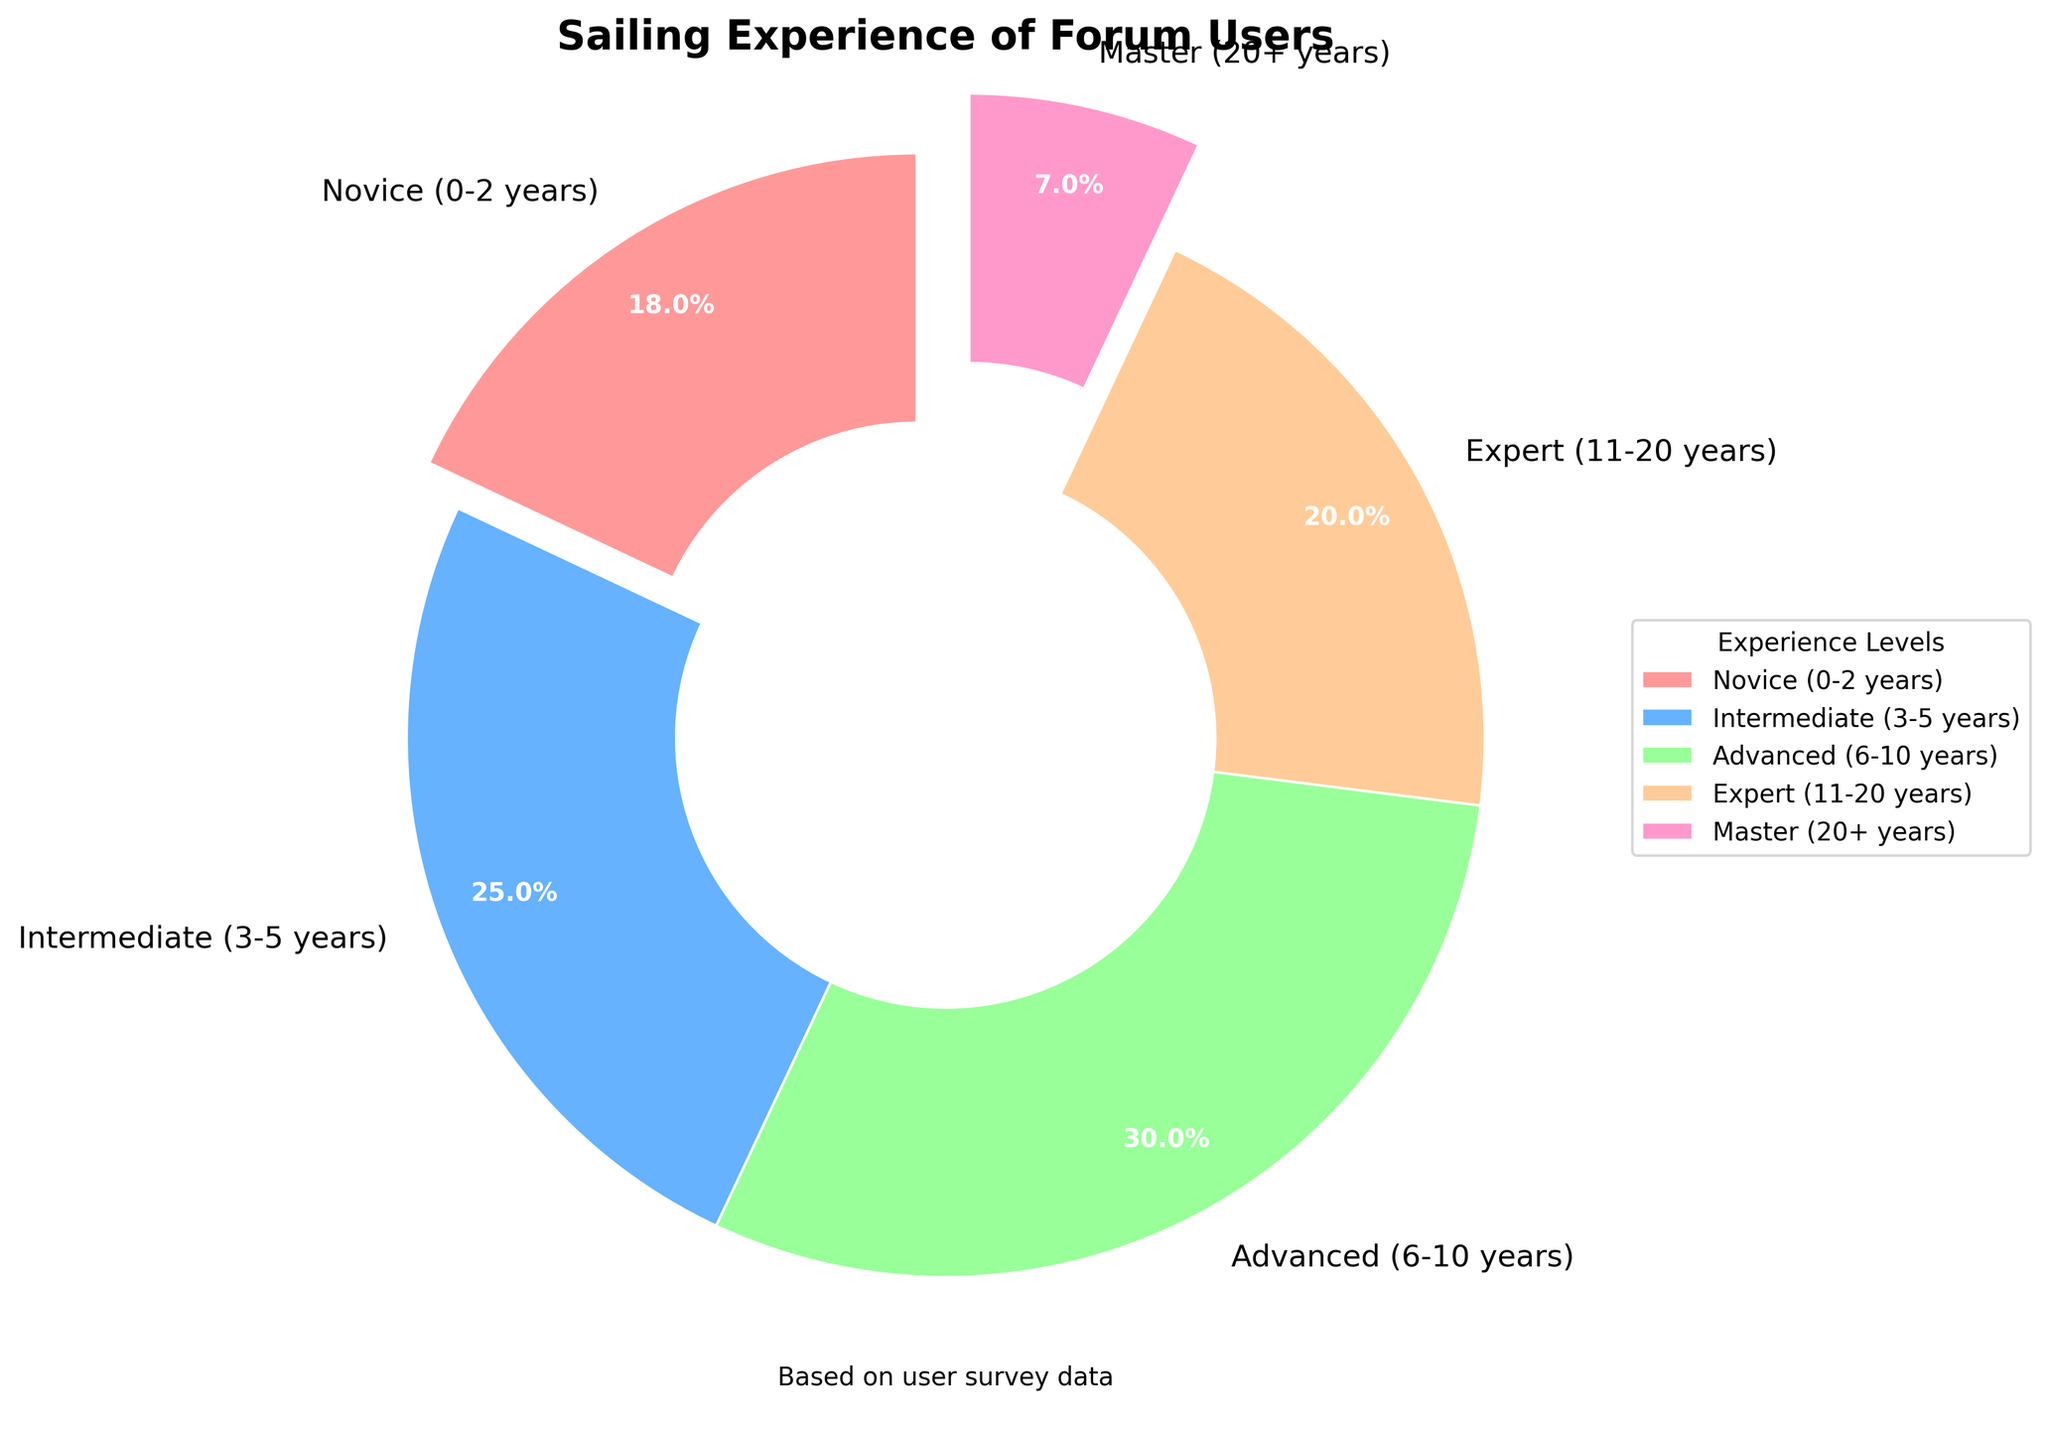What percentage of forum users are considered either Advanced or Expert sailors? To determine this, we sum the percentages of Advanced (30%) and Expert (20%) categories. 30 + 20 = 50%
Answer: 50% Which experience level has the smallest proportion of forum users? By looking at the pie chart, we see that the Master category has the smallest wedge, reflecting 7%.
Answer: Master How many times larger is the Intermediate group compared to the Master group? The Intermediate group is 25%, and the Master group is 7%. To find how many times larger, we divide 25 by 7. 25 / 7 ≈ 3.57
Answer: 3.57 times What is the difference in percentage between the most experienced group and the least experienced group? The Master group (7%) is the most experienced, and the Novice group (18%) is the least. We subtract 7 from 18. 18 - 7 = 11%
Answer: 11% Which two experience levels combined make up half of the forum users? Advanced (30%) and Expert (20%) combined equal 30 + 20 = 50% of the total.
Answer: Advanced and Expert What color is used to represent the Intermediate experience level in the pie chart? By looking at the pie chart, the Intermediate experience level is colored in blue.
Answer: Blue Is the percentage of Novice users greater or lesser than the percentage of Expert users? The Novice group is 18%, and the Expert group is 20%. 18% is less than 20%.
Answer: Lesser What is the visual difference in the pie slices between the Advanced group and the Master group? The Advanced group (30%) has a significantly larger pie slice than the Master group (7%), indicating Advanced is much more prevalent.
Answer: Advanced slice is larger If we were to average the percentages of Novice and Intermediate users, what would be the result? To find the average percentage, add Novice (18%) and Intermediate (25%) and divide by 2. (18 + 25) / 2 = 21.5%
Answer: 21.5% Which two experience levels have wedges that are not exploded in the pie chart? From observing the chart, Intermediate (25%) and Advanced (30%) have wedges that are not exploded.
Answer: Intermediate and Advanced 